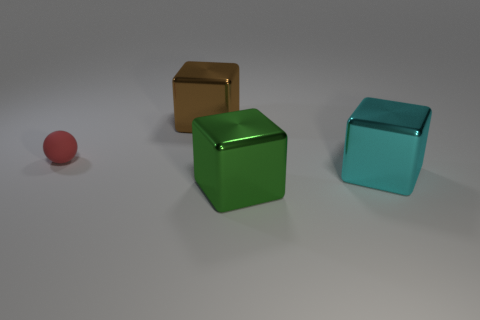There is a thing that is to the left of the metal thing that is behind the tiny ball; what is its color?
Your response must be concise. Red. Is the size of the red thing the same as the brown block?
Make the answer very short. No. Is the large object that is in front of the cyan object made of the same material as the cyan thing in front of the rubber object?
Your answer should be compact. Yes. What is the shape of the red matte thing that is on the left side of the metallic thing that is right of the large green thing that is right of the small thing?
Your response must be concise. Sphere. Are there more cyan metal spheres than red matte balls?
Provide a short and direct response. No. Are there any yellow shiny cylinders?
Keep it short and to the point. No. What number of things are objects in front of the cyan metal object or large shiny cubes in front of the brown block?
Give a very brief answer. 2. Are there fewer cyan blocks than big brown shiny spheres?
Your answer should be very brief. No. There is a big brown shiny object; are there any things behind it?
Give a very brief answer. No. Do the green cube and the big cyan thing have the same material?
Keep it short and to the point. Yes. 